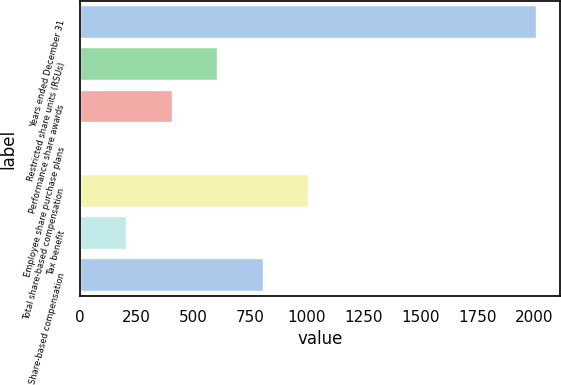<chart> <loc_0><loc_0><loc_500><loc_500><bar_chart><fcel>Years ended December 31<fcel>Restricted share units (RSUs)<fcel>Performance share awards<fcel>Employee share purchase plans<fcel>Total share-based compensation<fcel>Tax benefit<fcel>Share-based compensation<nl><fcel>2014<fcel>610.5<fcel>410<fcel>9<fcel>1011.5<fcel>209.5<fcel>811<nl></chart> 